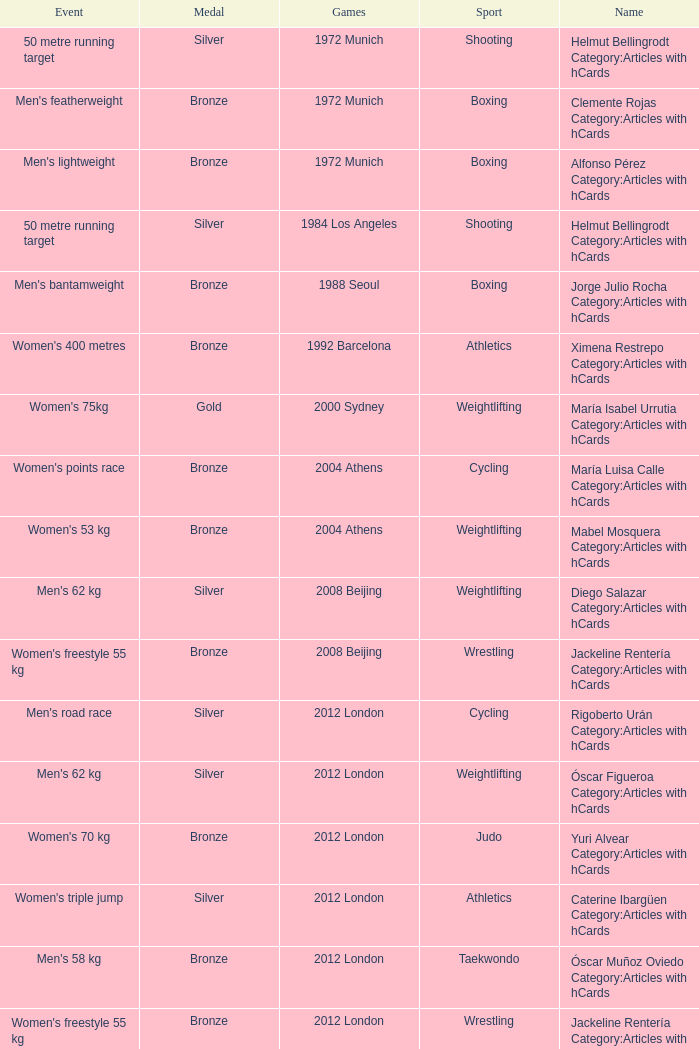Which wrestling event was at the 2008 Beijing games? Women's freestyle 55 kg. 